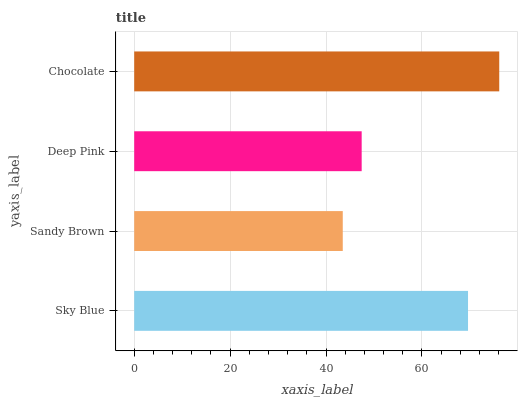Is Sandy Brown the minimum?
Answer yes or no. Yes. Is Chocolate the maximum?
Answer yes or no. Yes. Is Deep Pink the minimum?
Answer yes or no. No. Is Deep Pink the maximum?
Answer yes or no. No. Is Deep Pink greater than Sandy Brown?
Answer yes or no. Yes. Is Sandy Brown less than Deep Pink?
Answer yes or no. Yes. Is Sandy Brown greater than Deep Pink?
Answer yes or no. No. Is Deep Pink less than Sandy Brown?
Answer yes or no. No. Is Sky Blue the high median?
Answer yes or no. Yes. Is Deep Pink the low median?
Answer yes or no. Yes. Is Sandy Brown the high median?
Answer yes or no. No. Is Chocolate the low median?
Answer yes or no. No. 